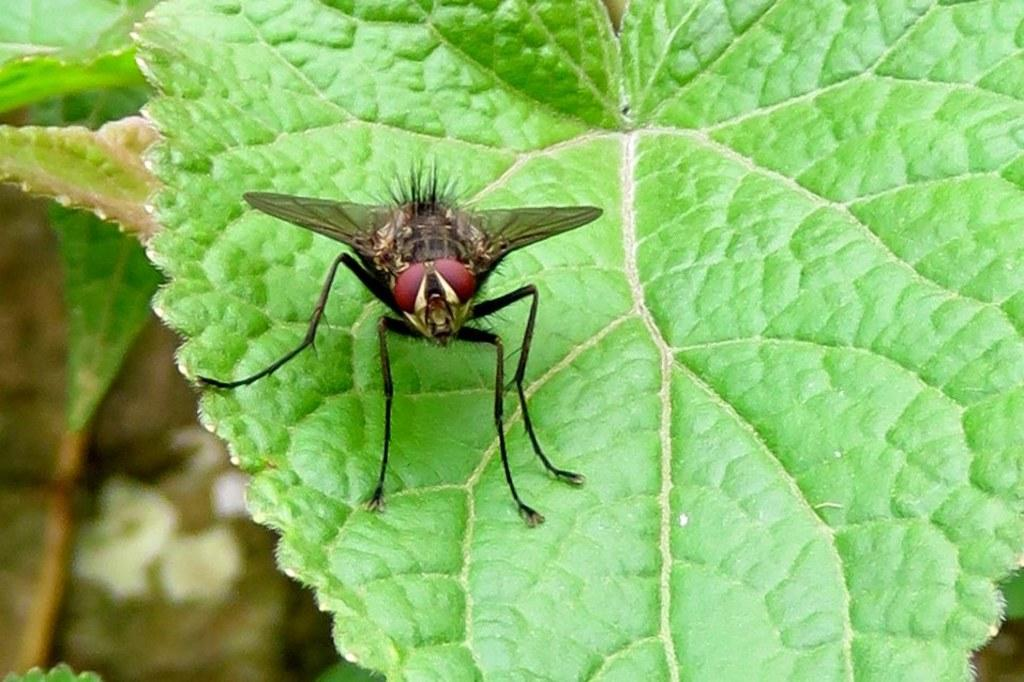What is on the leaf in the image? There is a fly on a leaf in the image. What can be seen on the left side of the image? There are leaves on the left side of the image. What is the price of the meat in the image? There is no meat or price information present in the image. 